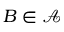Convert formula to latex. <formula><loc_0><loc_0><loc_500><loc_500>B \in { \mathcal { A } }</formula> 